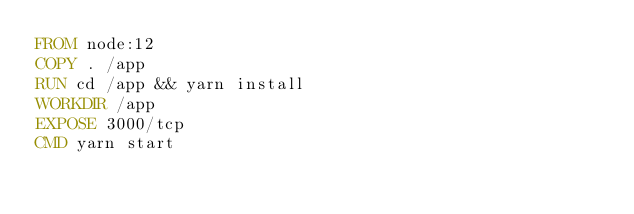<code> <loc_0><loc_0><loc_500><loc_500><_Dockerfile_>FROM node:12
COPY . /app
RUN cd /app && yarn install
WORKDIR /app
EXPOSE 3000/tcp
CMD yarn start</code> 